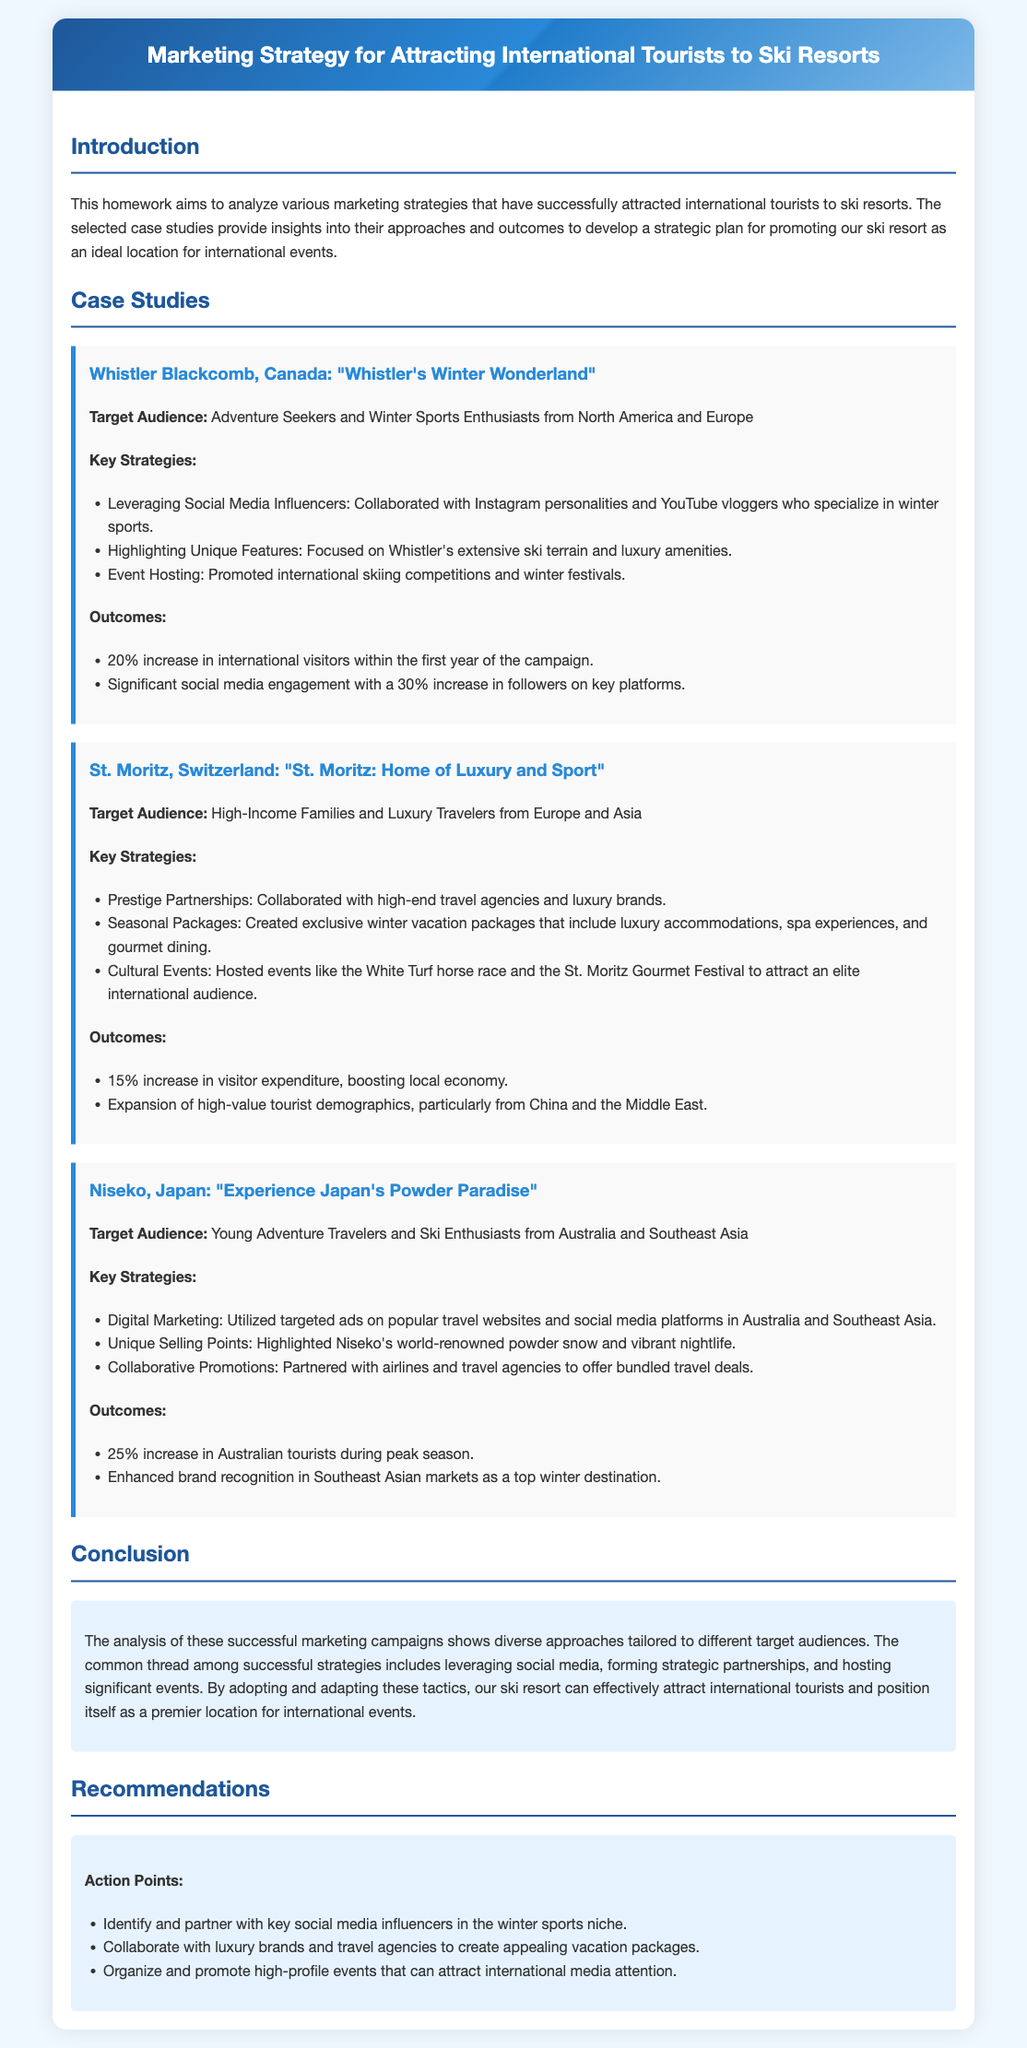What is the target audience for Whistler Blackcomb, Canada? The target audience is Adventure Seekers and Winter Sports Enthusiasts from North America and Europe.
Answer: Adventure Seekers and Winter Sports Enthusiasts from North America and Europe What was the outcome of the campaign for St. Moritz? The outcome of the campaign was a 15% increase in visitor expenditure, boosting the local economy.
Answer: 15% increase in visitor expenditure What social media strategy did Niseko utilize? Niseko utilized targeted ads on popular travel websites and social media platforms in Australia and Southeast Asia.
Answer: Targeted ads on popular travel websites and social media platforms What was the increase in international visitors for Whistler Blackcomb? The increase in international visitors was 20% within the first year of the campaign.
Answer: 20% increase Which luxury event was hosted in St. Moritz? The luxury event hosted in St. Moritz was the White Turf horse race.
Answer: White Turf horse race What is a common thread among successful marketing strategies? A common thread among successful strategies includes leveraging social media, forming strategic partnerships, and hosting significant events.
Answer: Leveraging social media, forming strategic partnerships, and hosting significant events What key action point is recommended for promoting the ski resort? The key action point is to identify and partner with key social media influencers in the winter sports niche.
Answer: Identify and partner with key social media influencers What kind of tourism did Niseko focus on attracting? Niseko focused on attracting Young Adventure Travelers and Ski Enthusiasts from Australia and Southeast Asia.
Answer: Young Adventure Travelers and Ski Enthusiasts from Australia and Southeast Asia 